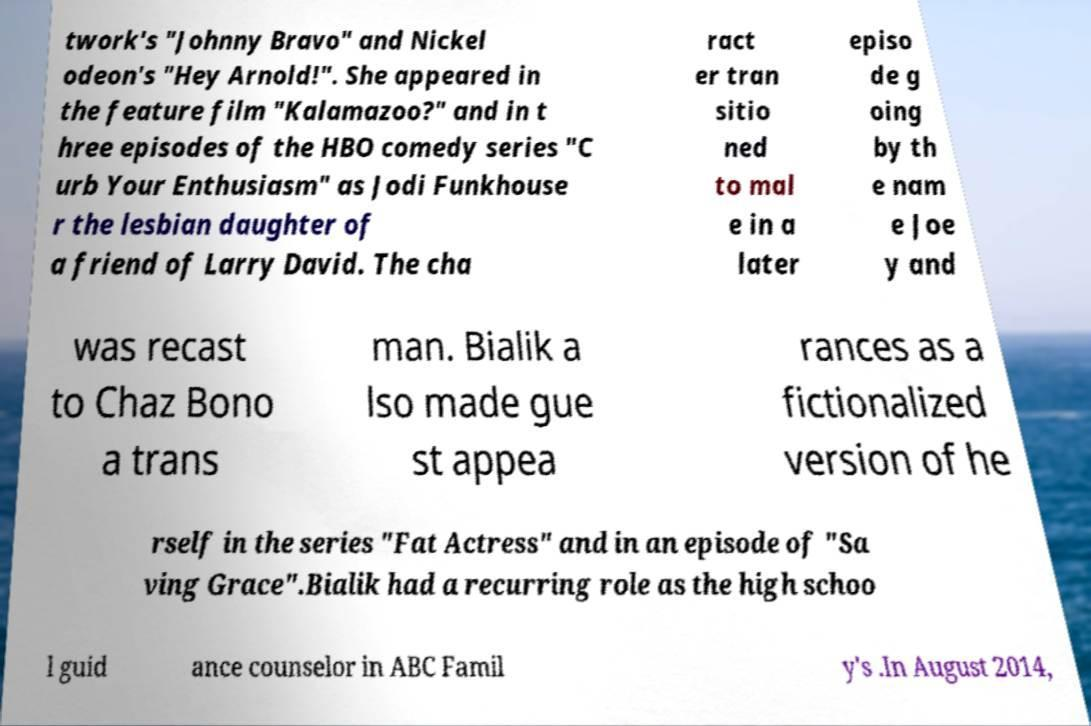What messages or text are displayed in this image? I need them in a readable, typed format. twork's "Johnny Bravo" and Nickel odeon's "Hey Arnold!". She appeared in the feature film "Kalamazoo?" and in t hree episodes of the HBO comedy series "C urb Your Enthusiasm" as Jodi Funkhouse r the lesbian daughter of a friend of Larry David. The cha ract er tran sitio ned to mal e in a later episo de g oing by th e nam e Joe y and was recast to Chaz Bono a trans man. Bialik a lso made gue st appea rances as a fictionalized version of he rself in the series "Fat Actress" and in an episode of "Sa ving Grace".Bialik had a recurring role as the high schoo l guid ance counselor in ABC Famil y's .In August 2014, 